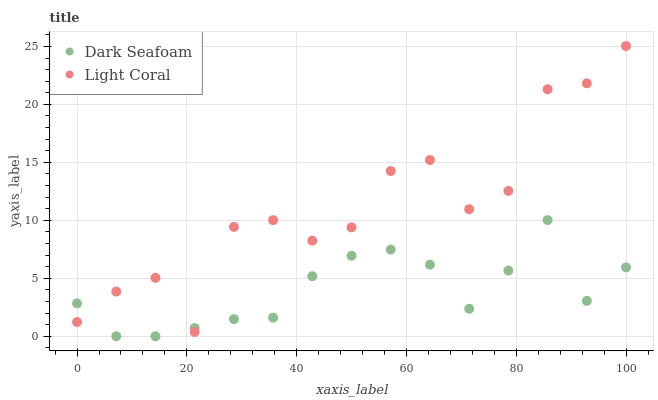Does Dark Seafoam have the minimum area under the curve?
Answer yes or no. Yes. Does Light Coral have the maximum area under the curve?
Answer yes or no. Yes. Does Dark Seafoam have the maximum area under the curve?
Answer yes or no. No. Is Dark Seafoam the smoothest?
Answer yes or no. Yes. Is Light Coral the roughest?
Answer yes or no. Yes. Is Dark Seafoam the roughest?
Answer yes or no. No. Does Dark Seafoam have the lowest value?
Answer yes or no. Yes. Does Light Coral have the highest value?
Answer yes or no. Yes. Does Dark Seafoam have the highest value?
Answer yes or no. No. Does Dark Seafoam intersect Light Coral?
Answer yes or no. Yes. Is Dark Seafoam less than Light Coral?
Answer yes or no. No. Is Dark Seafoam greater than Light Coral?
Answer yes or no. No. 